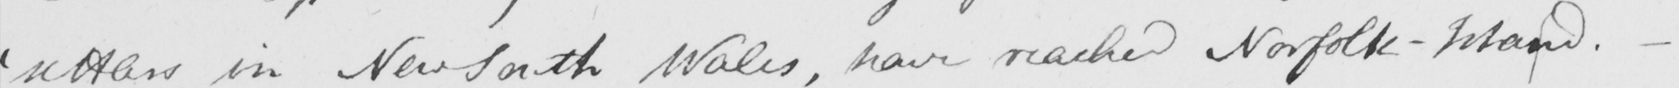Can you read and transcribe this handwriting? ' settlers in New South Wales , have reached Norfolk-Island .  _ 